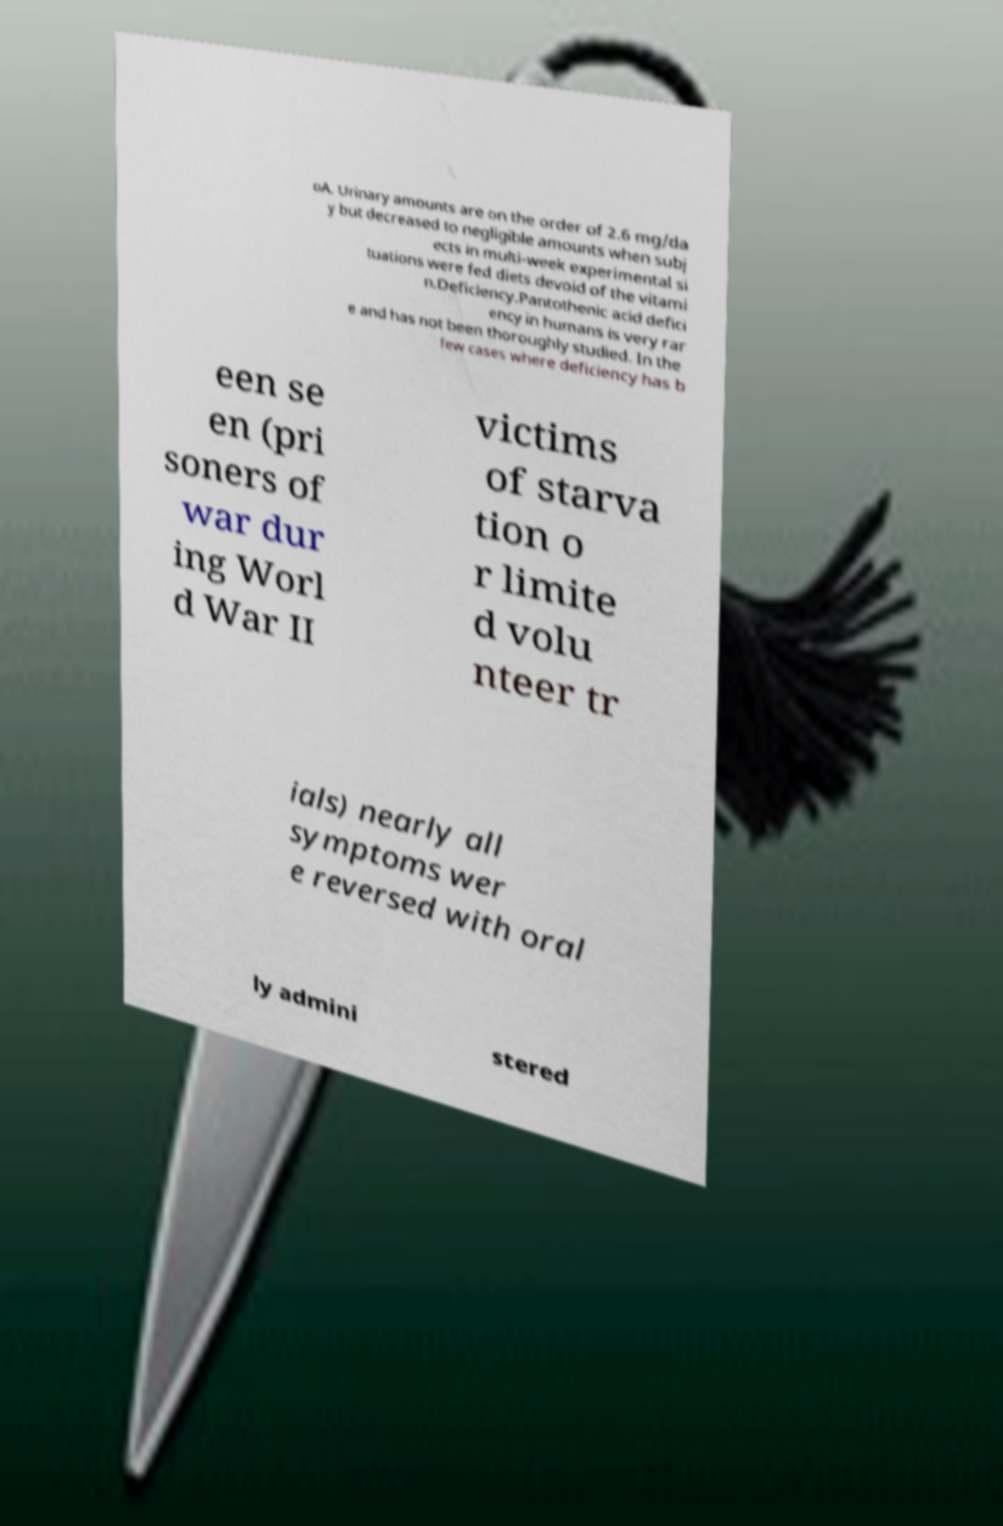For documentation purposes, I need the text within this image transcribed. Could you provide that? oA. Urinary amounts are on the order of 2.6 mg/da y but decreased to negligible amounts when subj ects in multi-week experimental si tuations were fed diets devoid of the vitami n.Deficiency.Pantothenic acid defici ency in humans is very rar e and has not been thoroughly studied. In the few cases where deficiency has b een se en (pri soners of war dur ing Worl d War II victims of starva tion o r limite d volu nteer tr ials) nearly all symptoms wer e reversed with oral ly admini stered 